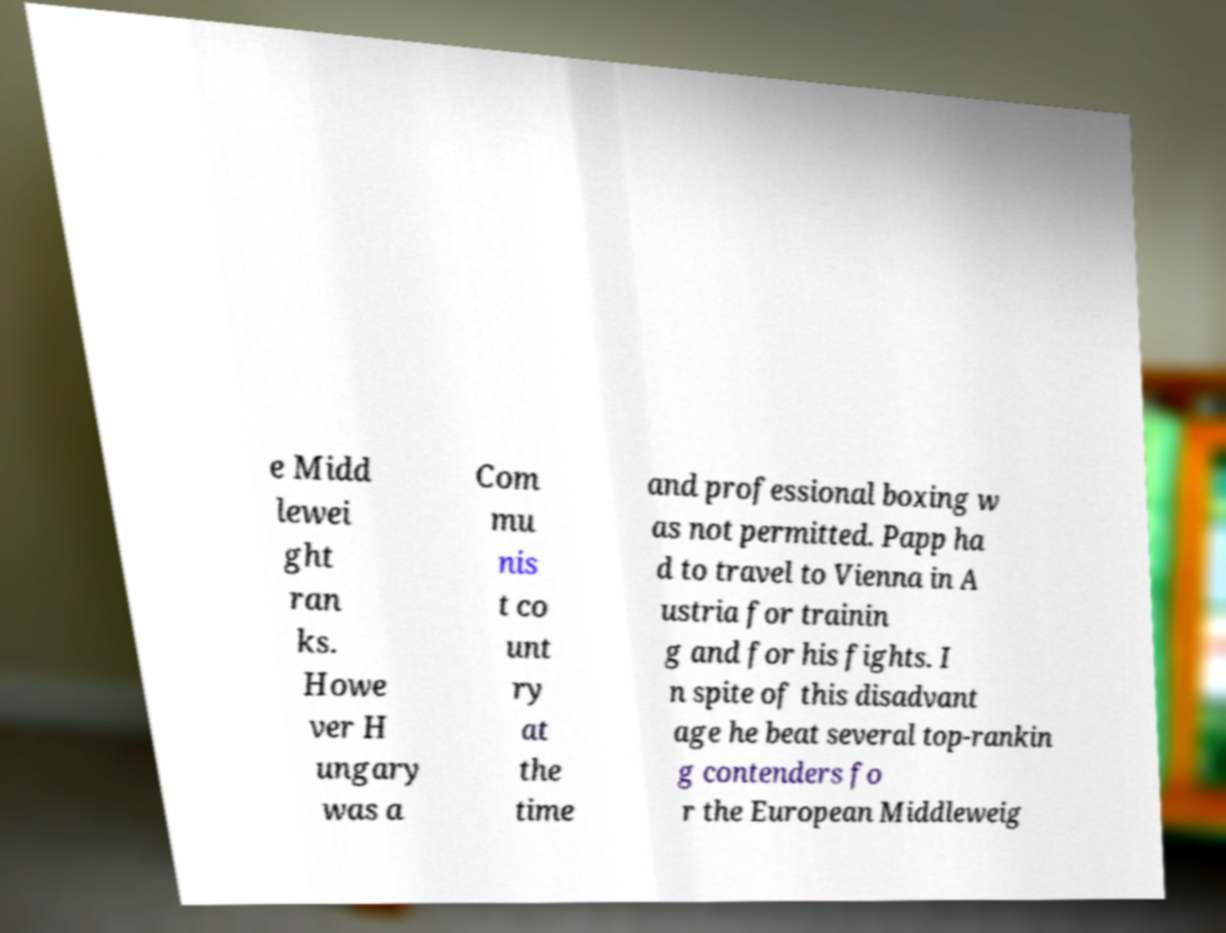Could you assist in decoding the text presented in this image and type it out clearly? e Midd lewei ght ran ks. Howe ver H ungary was a Com mu nis t co unt ry at the time and professional boxing w as not permitted. Papp ha d to travel to Vienna in A ustria for trainin g and for his fights. I n spite of this disadvant age he beat several top-rankin g contenders fo r the European Middleweig 